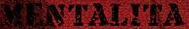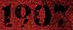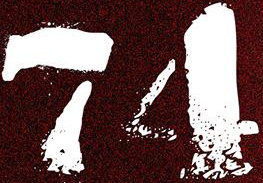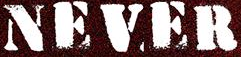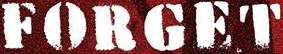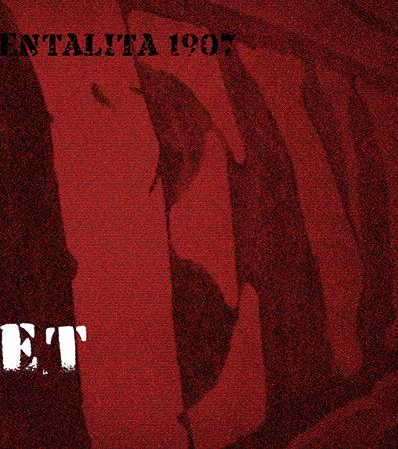What words can you see in these images in sequence, separated by a semicolon? MENTALITA; 1907; 74; NEVER; FORGET; EV 